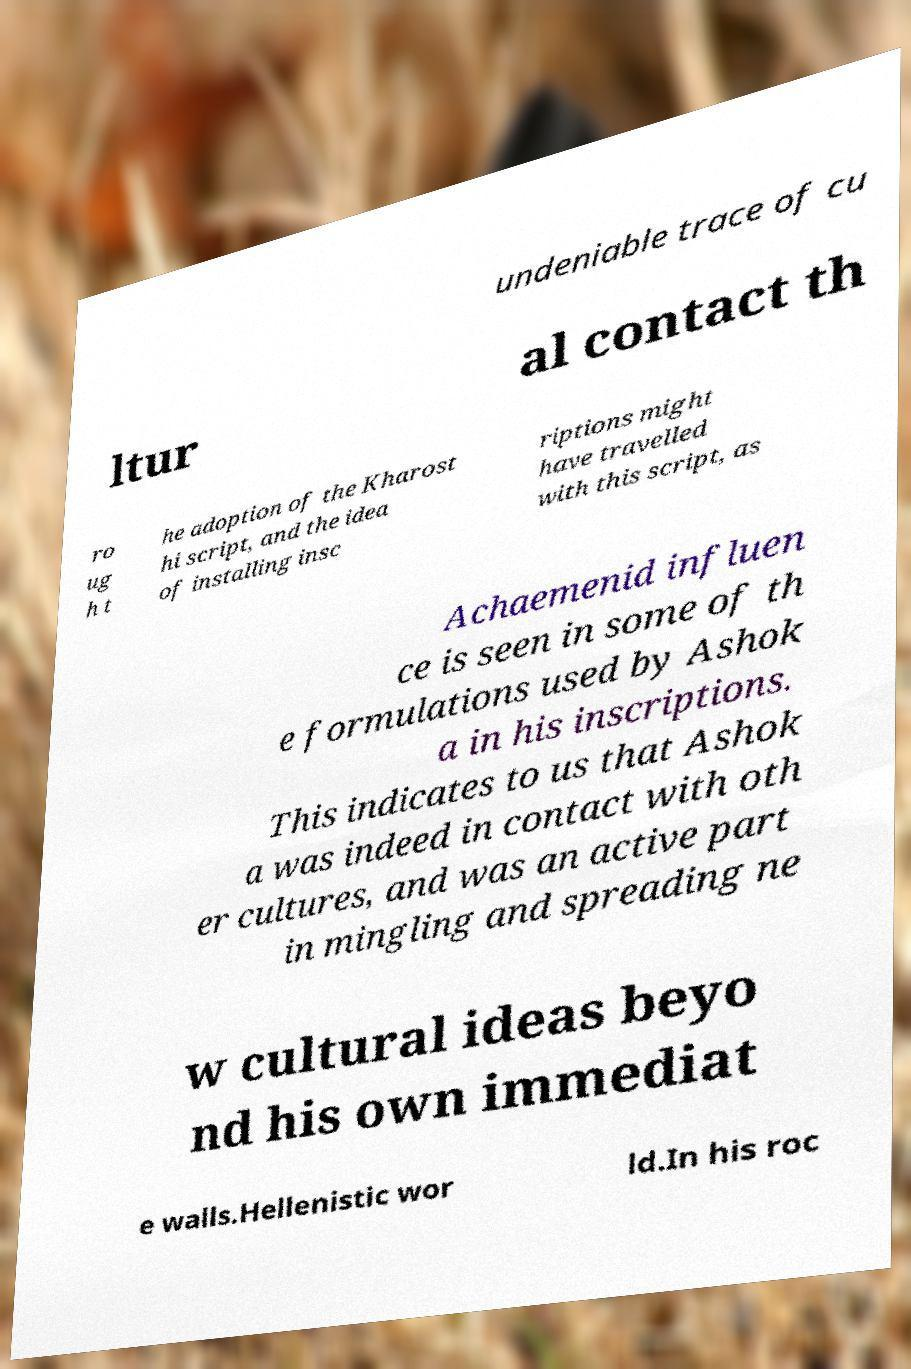Could you assist in decoding the text presented in this image and type it out clearly? undeniable trace of cu ltur al contact th ro ug h t he adoption of the Kharost hi script, and the idea of installing insc riptions might have travelled with this script, as Achaemenid influen ce is seen in some of th e formulations used by Ashok a in his inscriptions. This indicates to us that Ashok a was indeed in contact with oth er cultures, and was an active part in mingling and spreading ne w cultural ideas beyo nd his own immediat e walls.Hellenistic wor ld.In his roc 